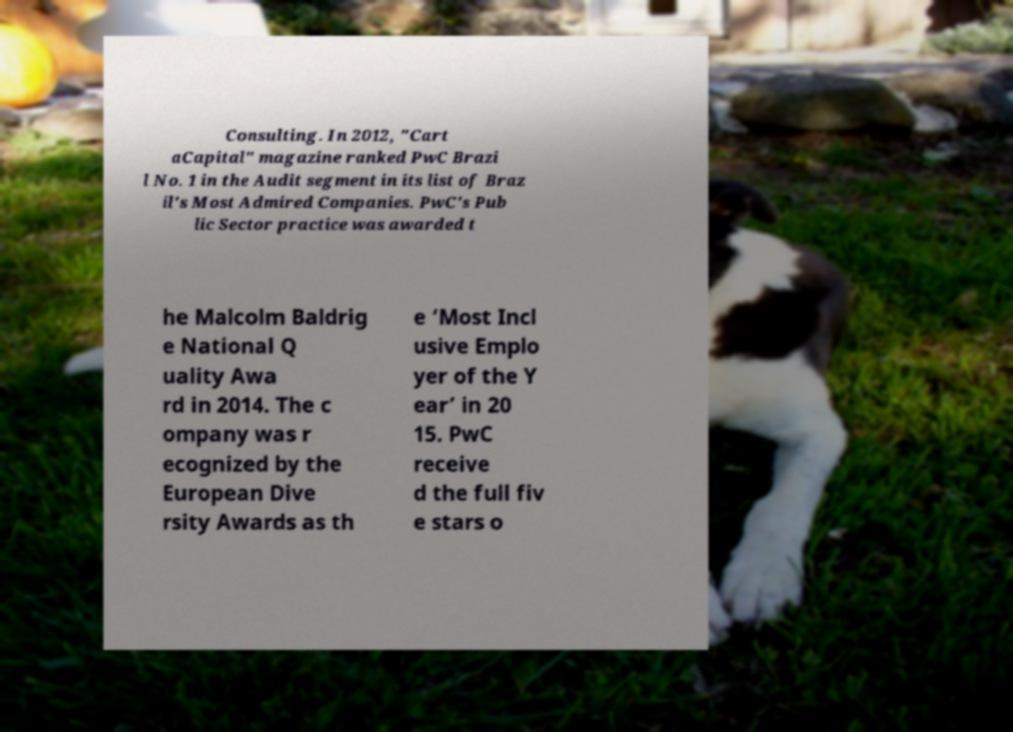What messages or text are displayed in this image? I need them in a readable, typed format. Consulting. In 2012, "Cart aCapital" magazine ranked PwC Brazi l No. 1 in the Audit segment in its list of Braz il's Most Admired Companies. PwC's Pub lic Sector practice was awarded t he Malcolm Baldrig e National Q uality Awa rd in 2014. The c ompany was r ecognized by the European Dive rsity Awards as th e ‘Most Incl usive Emplo yer of the Y ear’ in 20 15. PwC receive d the full fiv e stars o 